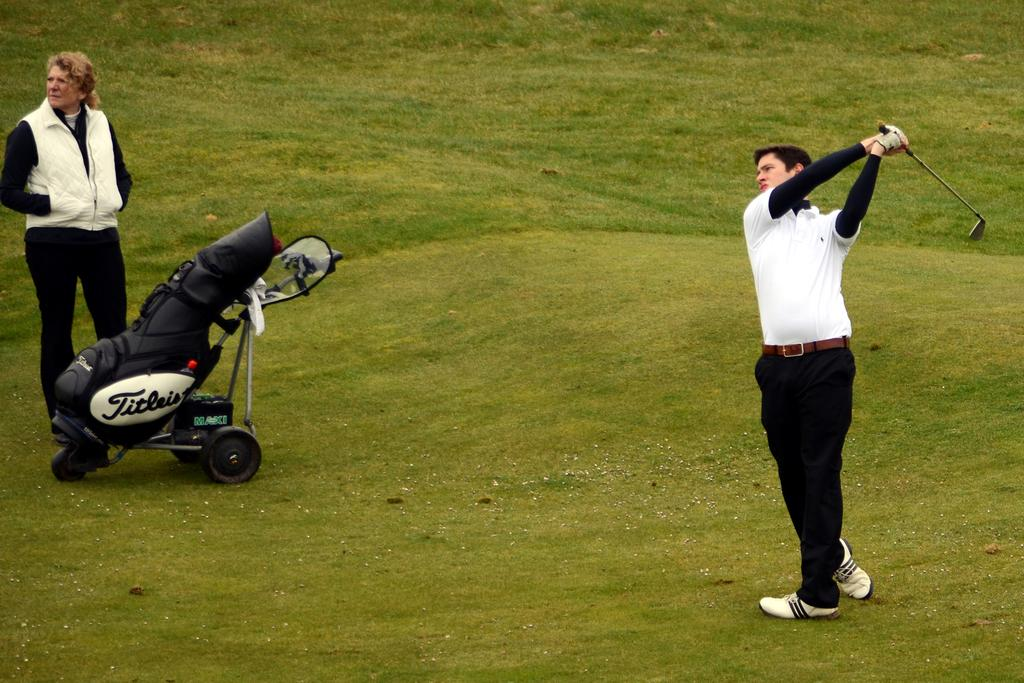How many people are in the image? There are two people in the image. What is on the ground in the image? There is a trolley on the ground. What is one of the men holding? One man is holding a stick. What type of natural environment is visible in the background of the image? There is grass visible in the background of the image. What is the price of the trolley in the image? The price of the trolley is not visible or mentioned in the image, so it cannot be determined. 